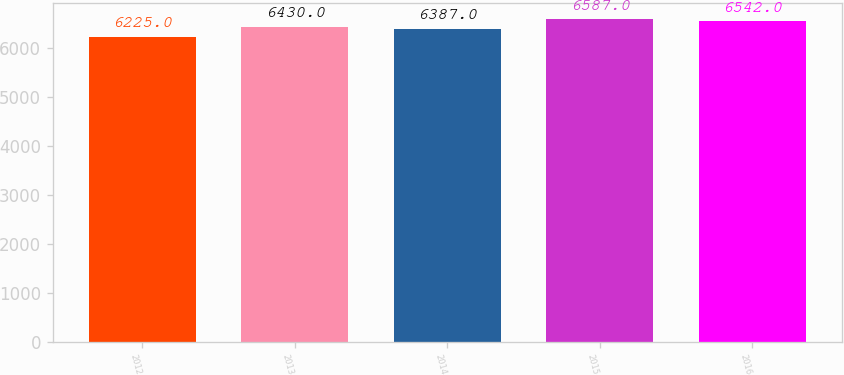Convert chart. <chart><loc_0><loc_0><loc_500><loc_500><bar_chart><fcel>2012<fcel>2013<fcel>2014<fcel>2015<fcel>2016<nl><fcel>6225<fcel>6430<fcel>6387<fcel>6587<fcel>6542<nl></chart> 